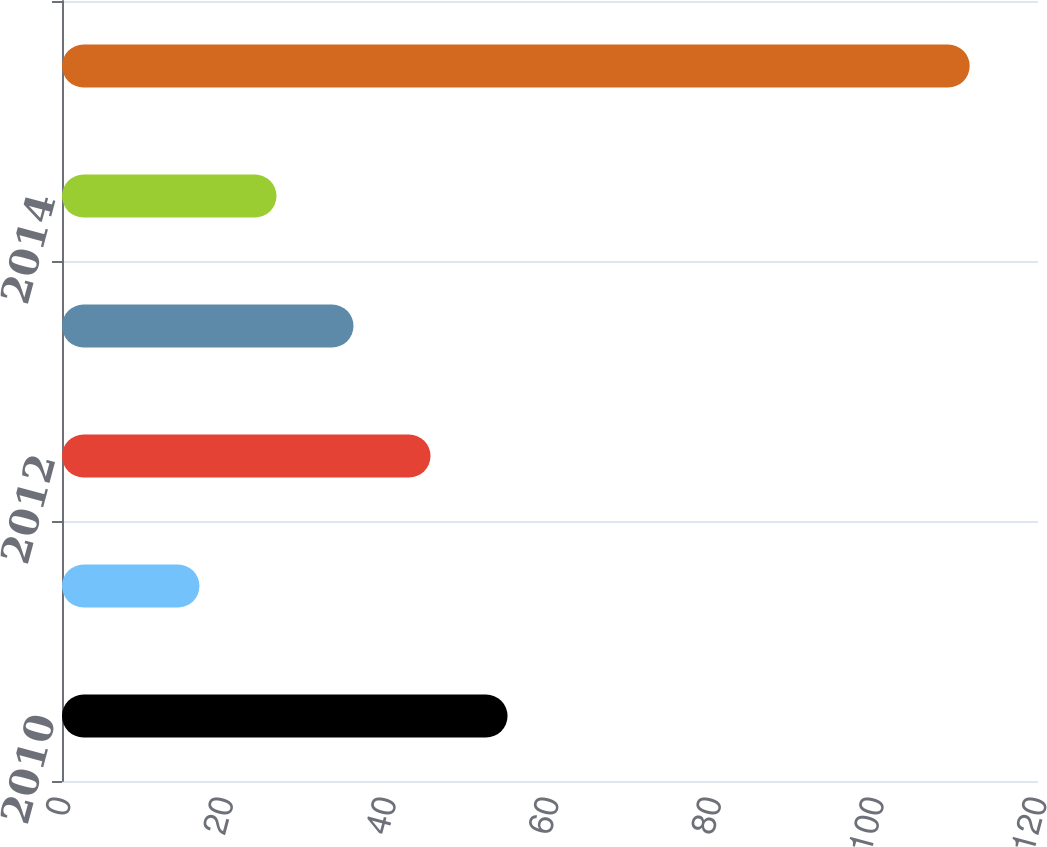Convert chart to OTSL. <chart><loc_0><loc_0><loc_500><loc_500><bar_chart><fcel>2010<fcel>2011<fcel>2012<fcel>2013<fcel>2014<fcel>Years 2015-2019<nl><fcel>54.78<fcel>16.9<fcel>45.31<fcel>35.84<fcel>26.37<fcel>111.6<nl></chart> 